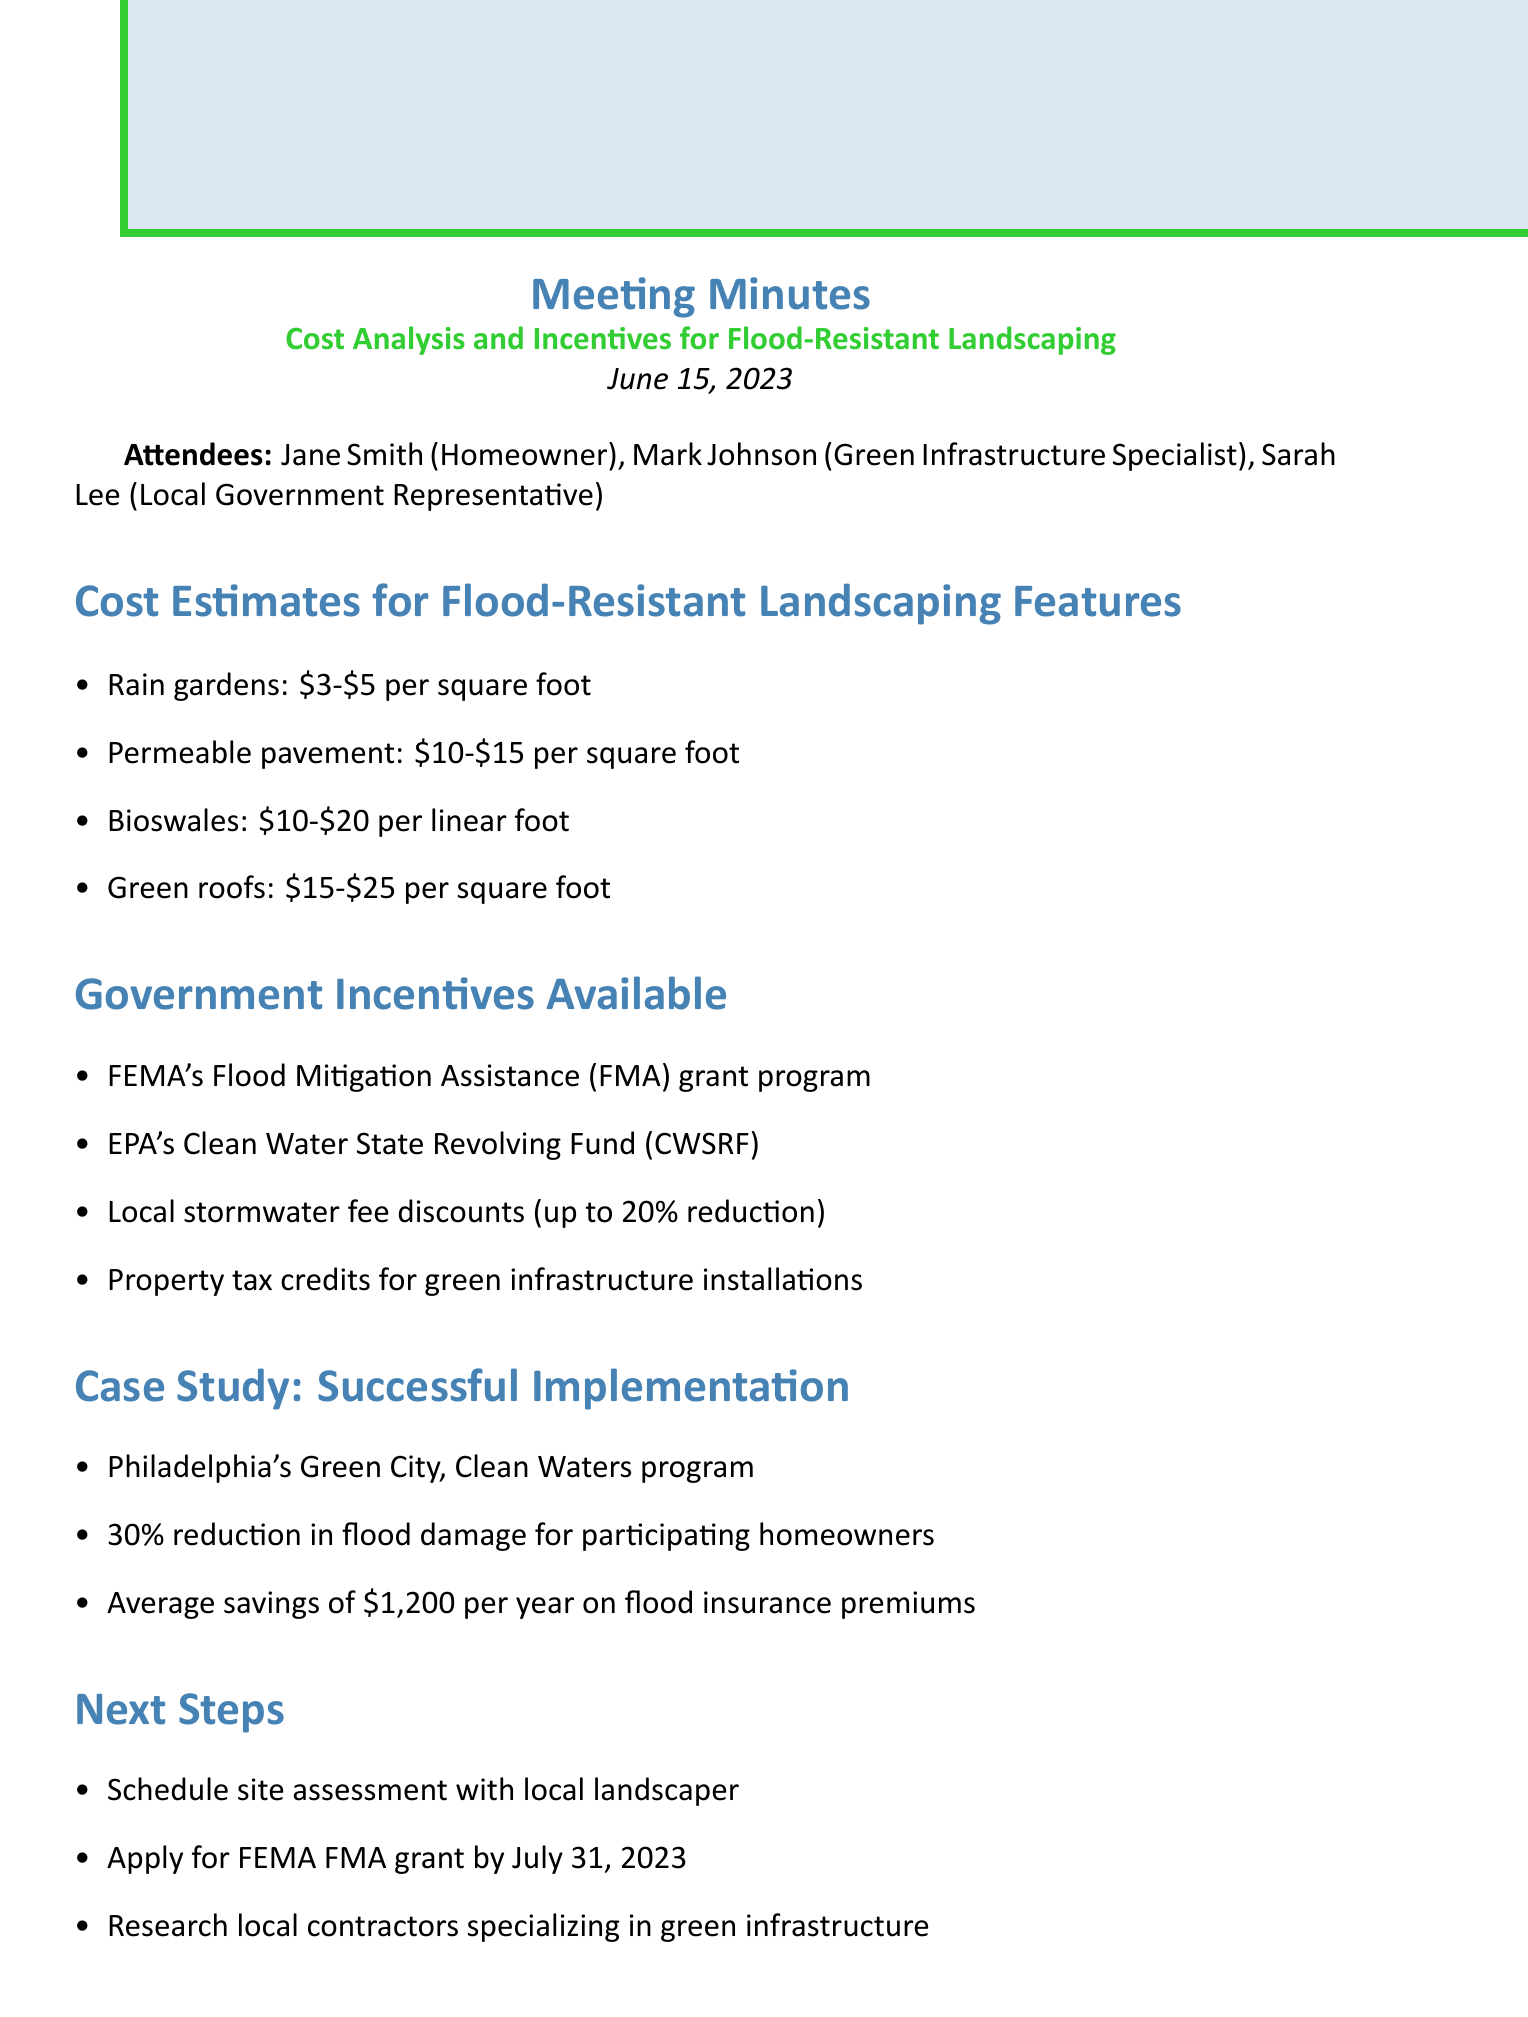What is the title of the meeting? The title of the meeting is presented at the top of the document, specifically listed as "Cost Analysis and Incentives for Flood-Resistant Landscaping."
Answer: Cost Analysis and Incentives for Flood-Resistant Landscaping What is the date of the meeting? The date of the meeting can be found just below the title, indicated as "June 15, 2023."
Answer: June 15, 2023 How much does permeable pavement cost per square foot? The cost estimate for permeable pavement is detailed in the cost estimates section, which indicates the price range is "$10-$15."
Answer: $10-$15 What is the percentage reduction in flood damage for participating homeowners in Philadelphia’s case study? The case study section provides a figure of a "30% reduction in flood damage" for homeowners participating in the program, highlighting its effectiveness.
Answer: 30% What program is associated with FEMA? In the government incentives section, it notes the "Flood Mitigation Assistance (FMA) grant program" as part of FEMA's initiatives.
Answer: Flood Mitigation Assistance What is the next step for homeowners after the meeting? The next steps section outlines several actions, one being to "Schedule site assessment with local landscaper" as necessary follow-up action.
Answer: Schedule site assessment Who is responsible for providing information on the CWSRF application process? The action items list assigns Mark the task to "provide detailed information on CWSRF application process," clarifying his role.
Answer: Mark What is one local government incentive mentioned? The government incentives section lists several options, one of which includes "Local stormwater fee discounts (up to 20% reduction)."
Answer: Local stormwater fee discounts What is an action item for Jane? The action items indicate Jane's responsibility to "gather quotes from three local landscapers," specifying her task post-meeting.
Answer: Gather quotes from three local landscapers 